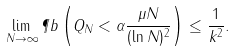<formula> <loc_0><loc_0><loc_500><loc_500>\lim _ { N \to \infty } { \P b \left ( Q _ { N } < \alpha \frac { \mu N } { ( \ln { N } ) ^ { 2 } } \right ) \leq \frac { 1 } { k ^ { 2 } } } .</formula> 